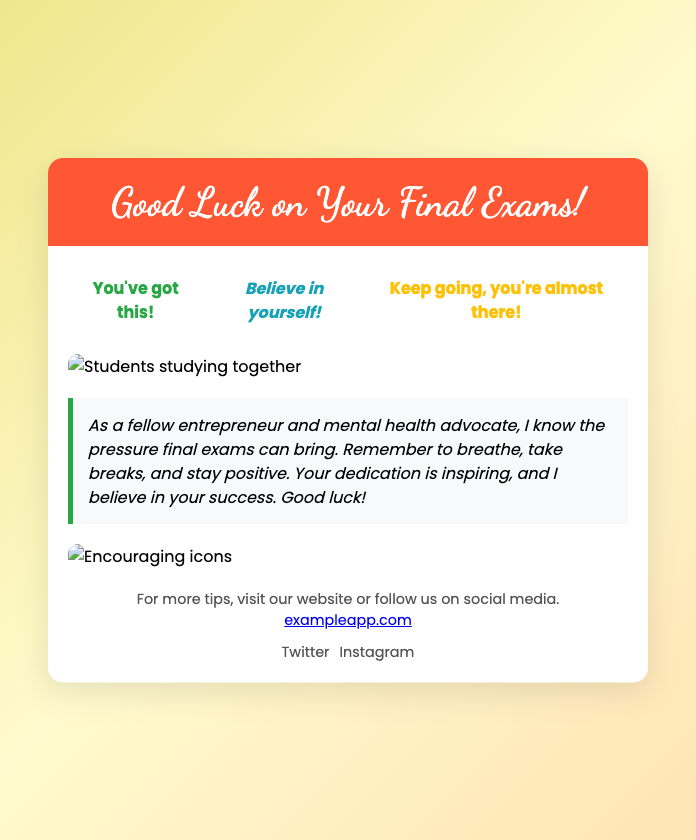What is the title of the card? The title of the card is displayed prominently in the header section of the document.
Answer: Good Luck on Your Final Exams! What colors are used in the background gradient? The background gradient uses a combination of three colors specified in the CSS.
Answer: #F0E68C, #FFFACD, #FFE4B5 How many motivational phrases are displayed? The document contains a section that lists multiple motivational phrases for encouragement.
Answer: Three What style of font is used for the card's header? The header uses a specific cursive font that is imported in the document's head section.
Answer: Dancing Script What is the main message conveyed in the personal message section? The personal message offers supportive advice regarding handling exam pressure, drawn from the context of being an advocate and entrepreneur.
Answer: Breathe, take breaks, and stay positive What is the theme of the images included in the card? The images included relate to students and studying, conveying an atmosphere of collaboration and support.
Answer: Students studying together What type of links are provided at the end of the card? The document encourages further engagement by providing links to a website and social media platforms.
Answer: Website and social media Which color represents one of the motivational phrases? The document specifies different colors for the motivational phrases to enhance visual appeal.
Answer: #28A745 